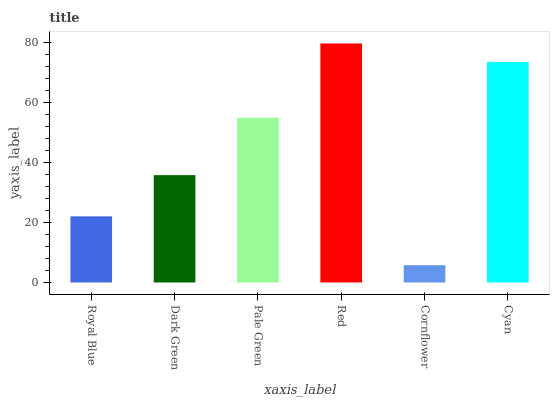Is Cornflower the minimum?
Answer yes or no. Yes. Is Red the maximum?
Answer yes or no. Yes. Is Dark Green the minimum?
Answer yes or no. No. Is Dark Green the maximum?
Answer yes or no. No. Is Dark Green greater than Royal Blue?
Answer yes or no. Yes. Is Royal Blue less than Dark Green?
Answer yes or no. Yes. Is Royal Blue greater than Dark Green?
Answer yes or no. No. Is Dark Green less than Royal Blue?
Answer yes or no. No. Is Pale Green the high median?
Answer yes or no. Yes. Is Dark Green the low median?
Answer yes or no. Yes. Is Royal Blue the high median?
Answer yes or no. No. Is Royal Blue the low median?
Answer yes or no. No. 